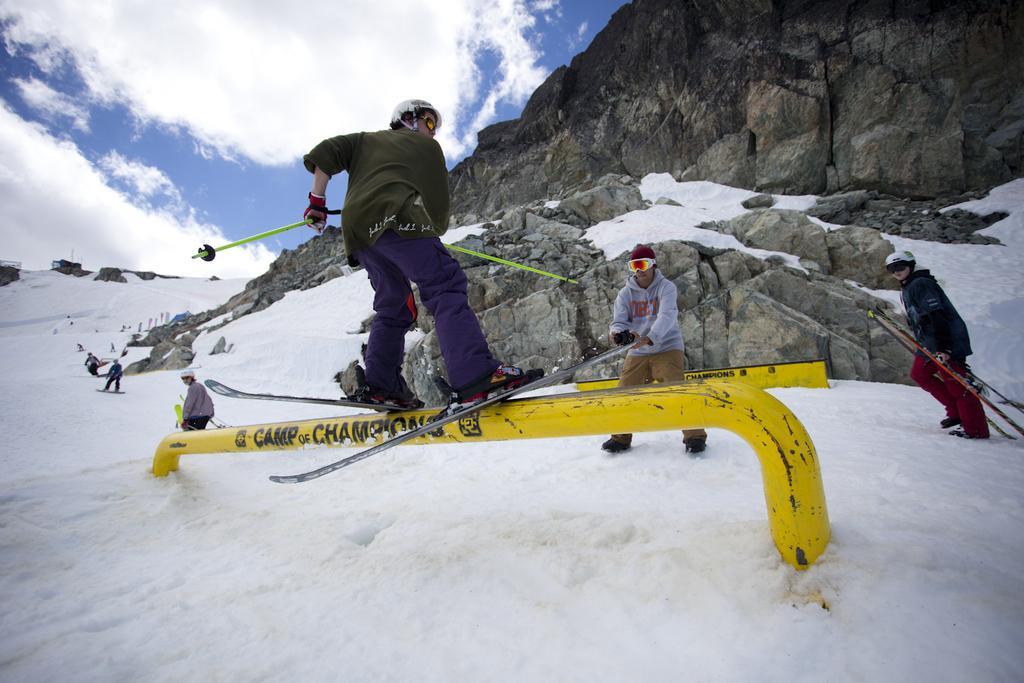Please provide a concise description of this image. In this image, I see a person who is on the ski and he is on the rod and the land is covered with the snow. In the background I see few people and there is a rock mountain over here and the sky. 